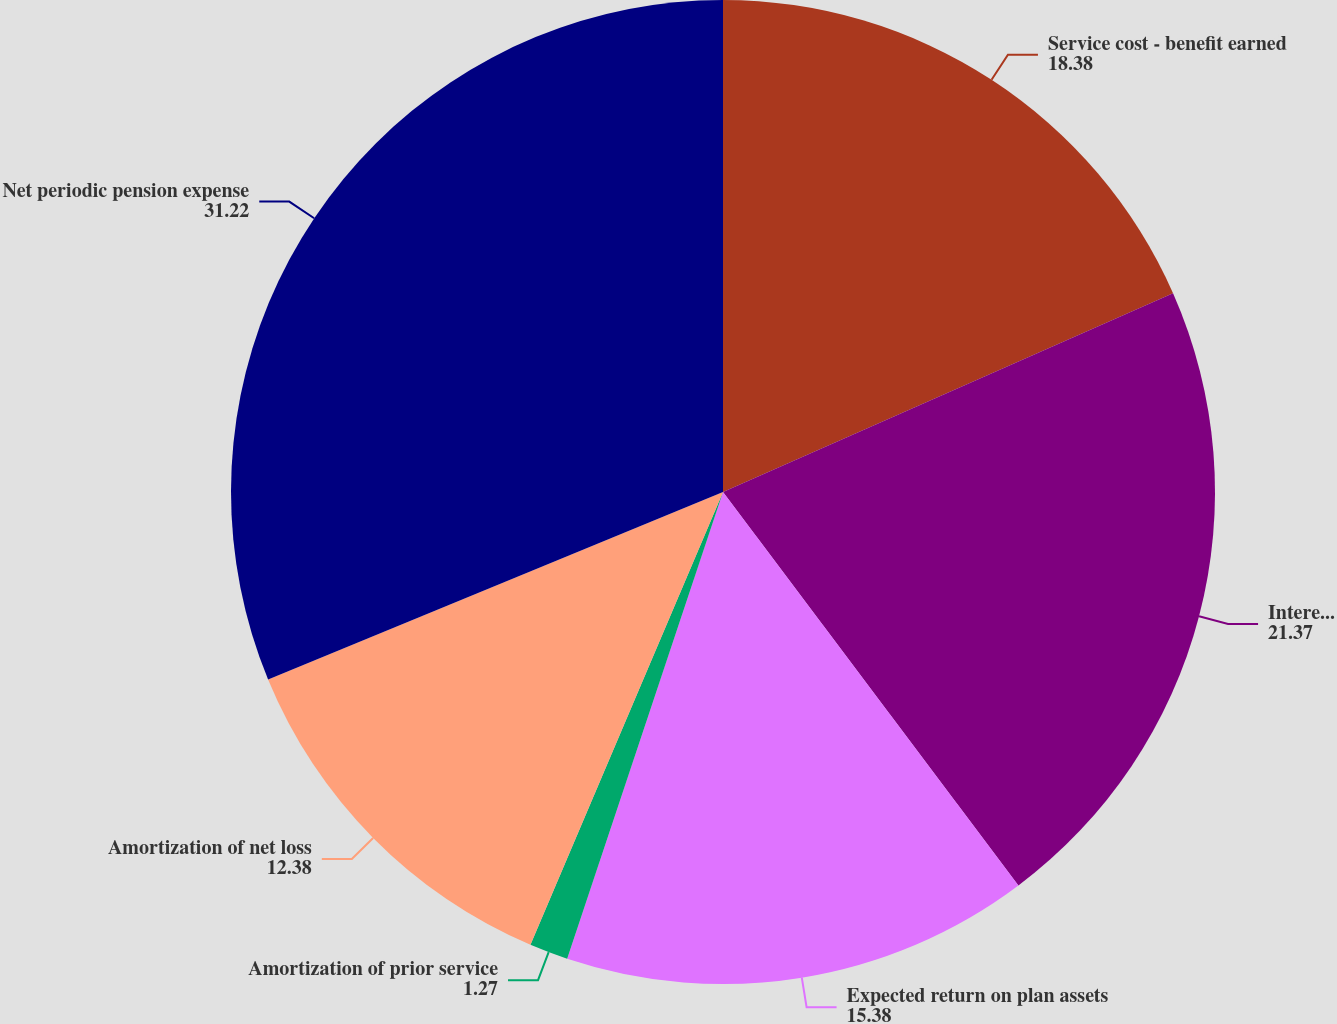<chart> <loc_0><loc_0><loc_500><loc_500><pie_chart><fcel>Service cost - benefit earned<fcel>Interest cost on projected<fcel>Expected return on plan assets<fcel>Amortization of prior service<fcel>Amortization of net loss<fcel>Net periodic pension expense<nl><fcel>18.38%<fcel>21.37%<fcel>15.38%<fcel>1.27%<fcel>12.38%<fcel>31.22%<nl></chart> 